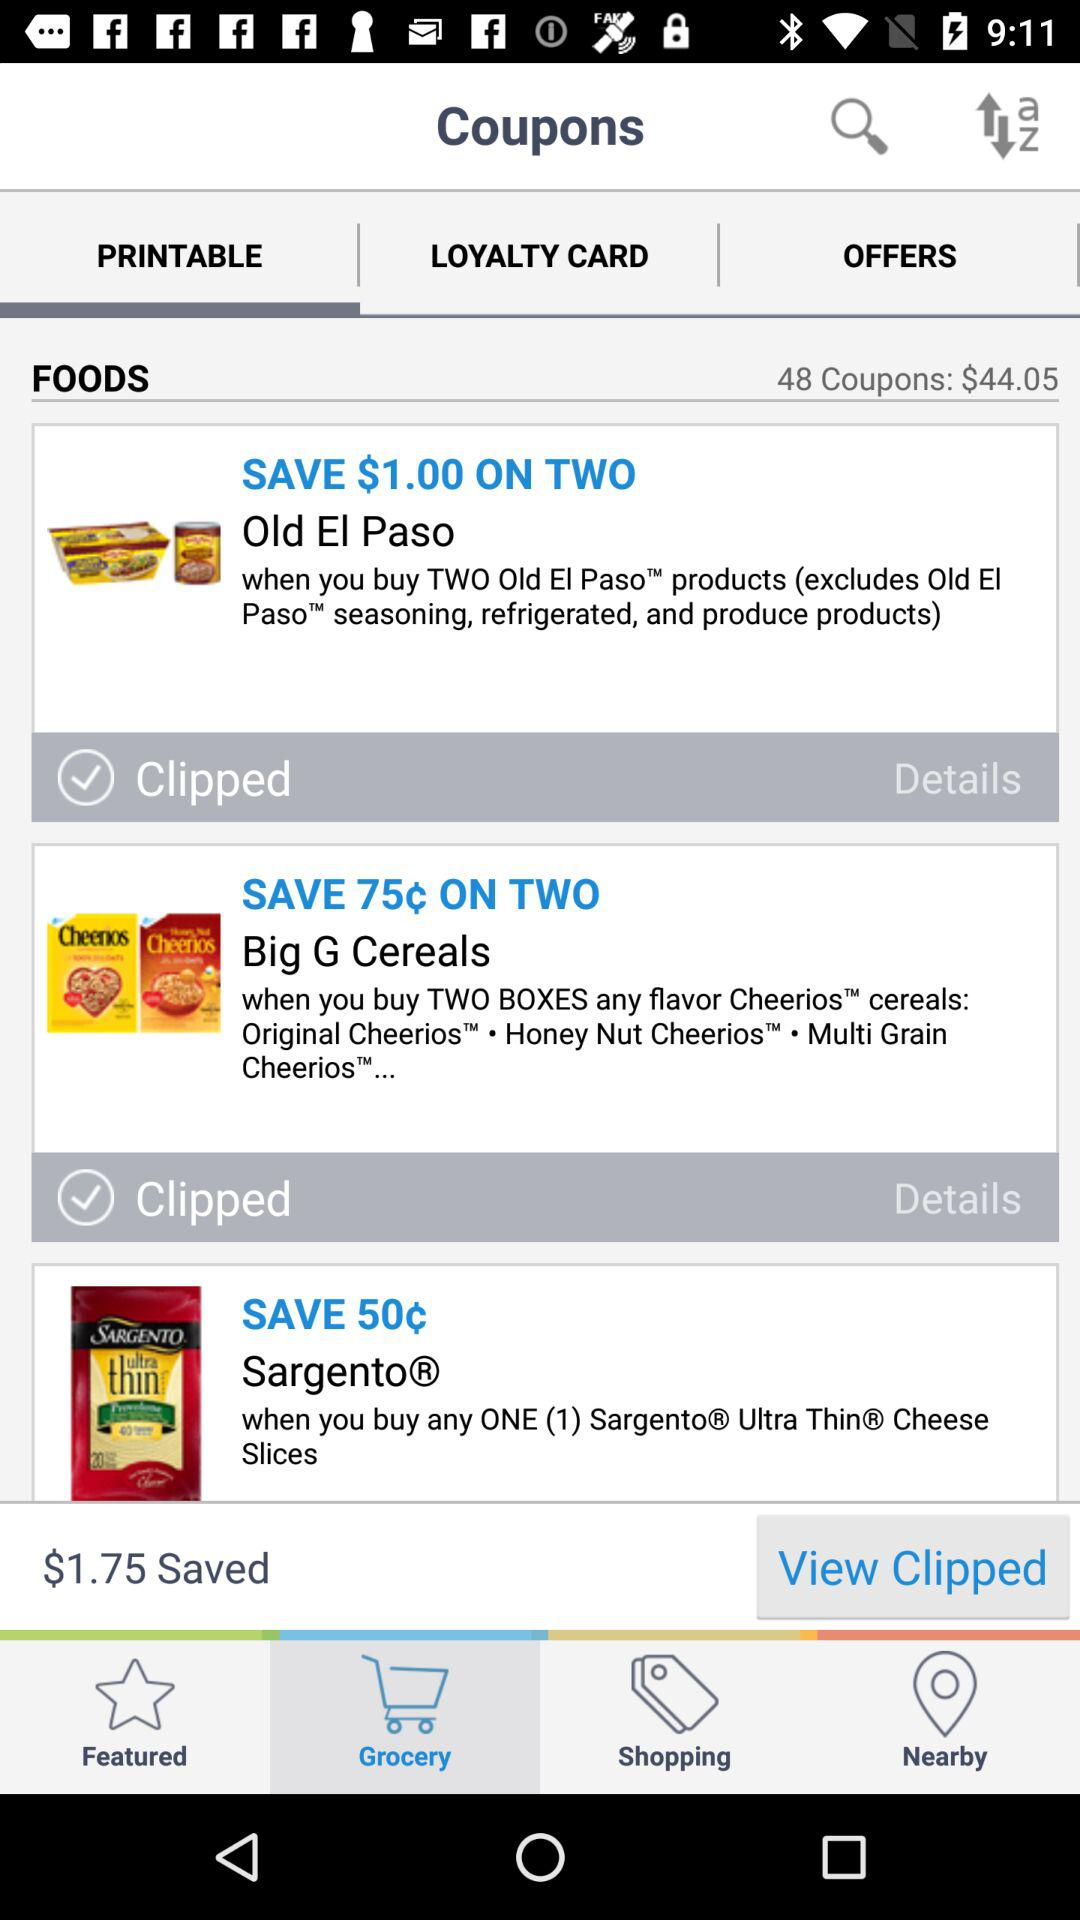What's the cost of 48 coupons? The cost of 48 coupons is $44.05. 